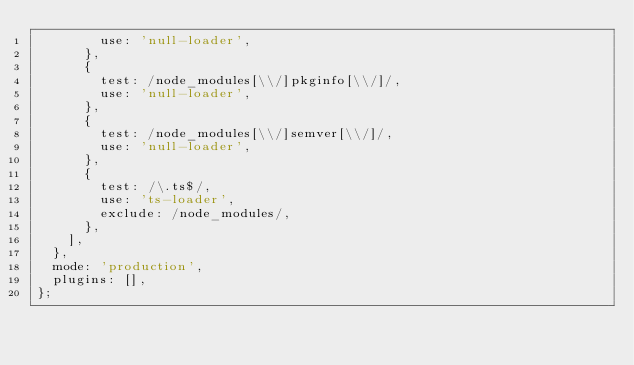Convert code to text. <code><loc_0><loc_0><loc_500><loc_500><_JavaScript_>        use: 'null-loader',
      },
      {
        test: /node_modules[\\/]pkginfo[\\/]/,
        use: 'null-loader',
      },
      {
        test: /node_modules[\\/]semver[\\/]/,
        use: 'null-loader',
      },
      {
        test: /\.ts$/,
        use: 'ts-loader',
        exclude: /node_modules/,
      },
    ],
  },
  mode: 'production',
  plugins: [],
};
</code> 